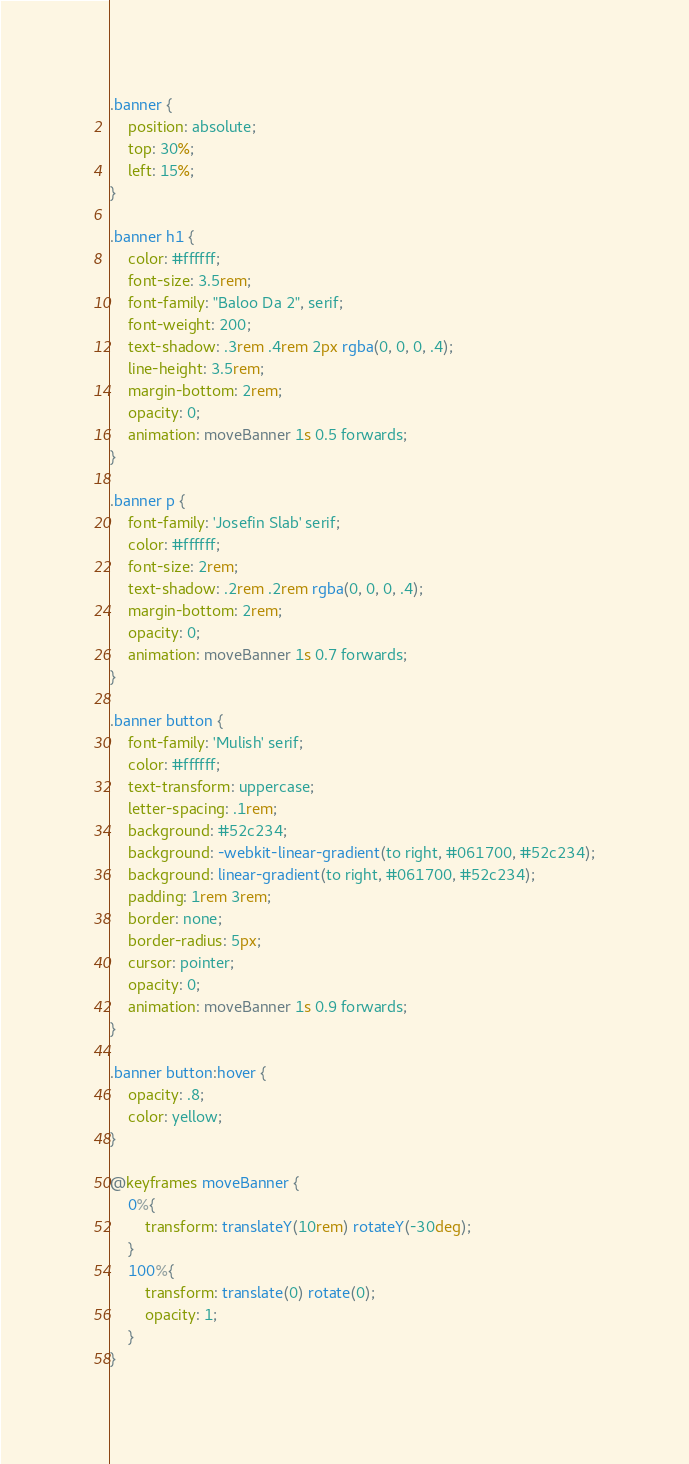<code> <loc_0><loc_0><loc_500><loc_500><_CSS_>.banner {
    position: absolute;
    top: 30%;
    left: 15%;
}

.banner h1 {
    color: #ffffff;
    font-size: 3.5rem;
    font-family: "Baloo Da 2", serif;
    font-weight: 200;
    text-shadow: .3rem .4rem 2px rgba(0, 0, 0, .4);
    line-height: 3.5rem;
    margin-bottom: 2rem;
    opacity: 0;
    animation: moveBanner 1s 0.5 forwards;
}

.banner p {
    font-family: 'Josefin Slab' serif;
    color: #ffffff;
    font-size: 2rem;
    text-shadow: .2rem .2rem rgba(0, 0, 0, .4);
    margin-bottom: 2rem;
    opacity: 0;
    animation: moveBanner 1s 0.7 forwards;
}

.banner button {
    font-family: 'Mulish' serif;
    color: #ffffff;
    text-transform: uppercase;
    letter-spacing: .1rem;
    background: #52c234;
    background: -webkit-linear-gradient(to right, #061700, #52c234);
    background: linear-gradient(to right, #061700, #52c234);
    padding: 1rem 3rem;
    border: none;
    border-radius: 5px;
    cursor: pointer;
    opacity: 0;
    animation: moveBanner 1s 0.9 forwards;
}

.banner button:hover {
    opacity: .8;
    color: yellow;
}

@keyframes moveBanner {
    0%{
        transform: translateY(10rem) rotateY(-30deg);
    }
    100%{
        transform: translate(0) rotate(0);
        opacity: 1;
    }
}</code> 